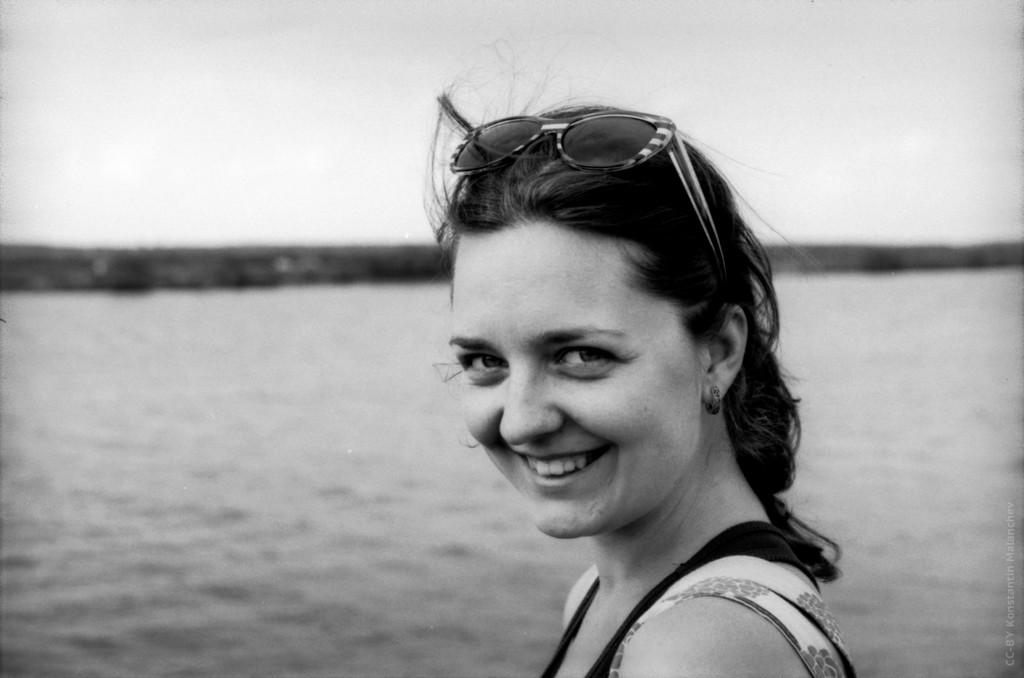What is the color scheme of the image? The image is black and white. Who is present in the image? There is a lady in the image. What is the lady wearing on her head? The lady is wearing goggles on her head. What can be seen in the background of the image? There is water and the sky visible in the background of the image. What is the lady's opinion on waste management in the image? There is no information about the lady's opinion on waste management in the image. Can you tell me how many chairs are visible in the image? There are no chairs present in the image. 